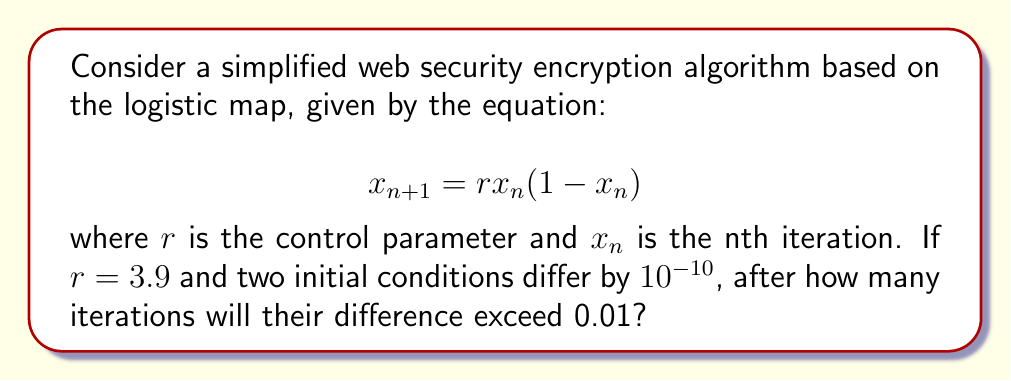What is the answer to this math problem? To solve this problem, we'll use the concept of Lyapunov exponent, which measures the rate of divergence of nearby trajectories in a chaotic system.

Step 1: Calculate the Lyapunov exponent λ for the logistic map with r = 3.9.
The formula for λ is:
$$λ = \lim_{n→∞} \frac{1}{n} \sum_{i=0}^{n-1} \ln|r(1-2x_i)|$$

For r = 3.9, λ ≈ 0.6946 (this value can be approximated numerically).

Step 2: Use the Lyapunov exponent to estimate the number of iterations.
The divergence of two nearby trajectories can be approximated by:
$$d_n ≈ d_0 e^{λn}$$

where $d_0$ is the initial difference and $d_n$ is the difference after n iterations.

Step 3: Solve for n.
We want to find n such that:
$$0.01 = 10^{-10} e^{0.6946n}$$

Taking the natural log of both sides:
$$\ln(0.01) = \ln(10^{-10}) + 0.6946n$$

Solving for n:
$$n = \frac{\ln(0.01) - \ln(10^{-10})}{0.6946} ≈ 22.95$$

Step 4: Round up to the nearest integer since we need the first iteration where the difference exceeds 0.01.
Answer: 23 iterations 